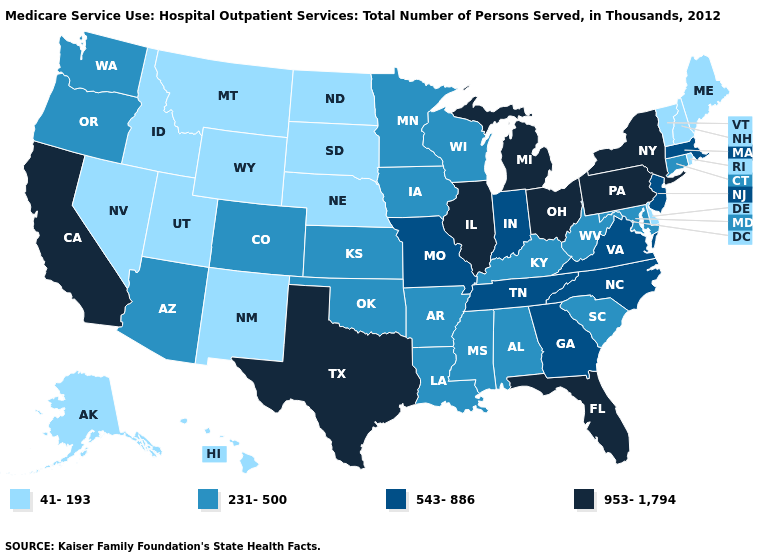What is the value of Utah?
Quick response, please. 41-193. How many symbols are there in the legend?
Short answer required. 4. Name the states that have a value in the range 543-886?
Be succinct. Georgia, Indiana, Massachusetts, Missouri, New Jersey, North Carolina, Tennessee, Virginia. Among the states that border Idaho , does Oregon have the highest value?
Give a very brief answer. Yes. Name the states that have a value in the range 231-500?
Give a very brief answer. Alabama, Arizona, Arkansas, Colorado, Connecticut, Iowa, Kansas, Kentucky, Louisiana, Maryland, Minnesota, Mississippi, Oklahoma, Oregon, South Carolina, Washington, West Virginia, Wisconsin. Does Delaware have the lowest value in the South?
Quick response, please. Yes. What is the value of Georgia?
Be succinct. 543-886. Does the map have missing data?
Short answer required. No. Name the states that have a value in the range 953-1,794?
Keep it brief. California, Florida, Illinois, Michigan, New York, Ohio, Pennsylvania, Texas. Does Louisiana have the same value as Connecticut?
Concise answer only. Yes. How many symbols are there in the legend?
Quick response, please. 4. Which states have the lowest value in the USA?
Write a very short answer. Alaska, Delaware, Hawaii, Idaho, Maine, Montana, Nebraska, Nevada, New Hampshire, New Mexico, North Dakota, Rhode Island, South Dakota, Utah, Vermont, Wyoming. Does Texas have a lower value than New Hampshire?
Give a very brief answer. No. Does Maine have the lowest value in the Northeast?
Quick response, please. Yes. 